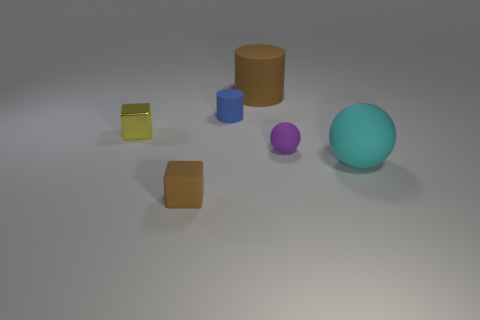Are the sphere that is right of the tiny purple matte object and the small sphere made of the same material?
Your answer should be very brief. Yes. How many objects are things or matte things to the right of the brown cube?
Give a very brief answer. 6. What color is the big ball that is the same material as the purple object?
Keep it short and to the point. Cyan. What number of yellow spheres have the same material as the large brown cylinder?
Offer a very short reply. 0. How many red matte cylinders are there?
Give a very brief answer. 0. There is a small matte object that is in front of the purple rubber sphere; does it have the same color as the cylinder that is behind the blue thing?
Offer a very short reply. Yes. What number of brown things are to the right of the purple matte sphere?
Make the answer very short. 0. Are there any other small things of the same shape as the cyan object?
Give a very brief answer. Yes. Are the sphere behind the cyan ball and the small object behind the tiny yellow block made of the same material?
Provide a short and direct response. Yes. What size is the brown matte object behind the object in front of the sphere that is in front of the small purple object?
Make the answer very short. Large. 